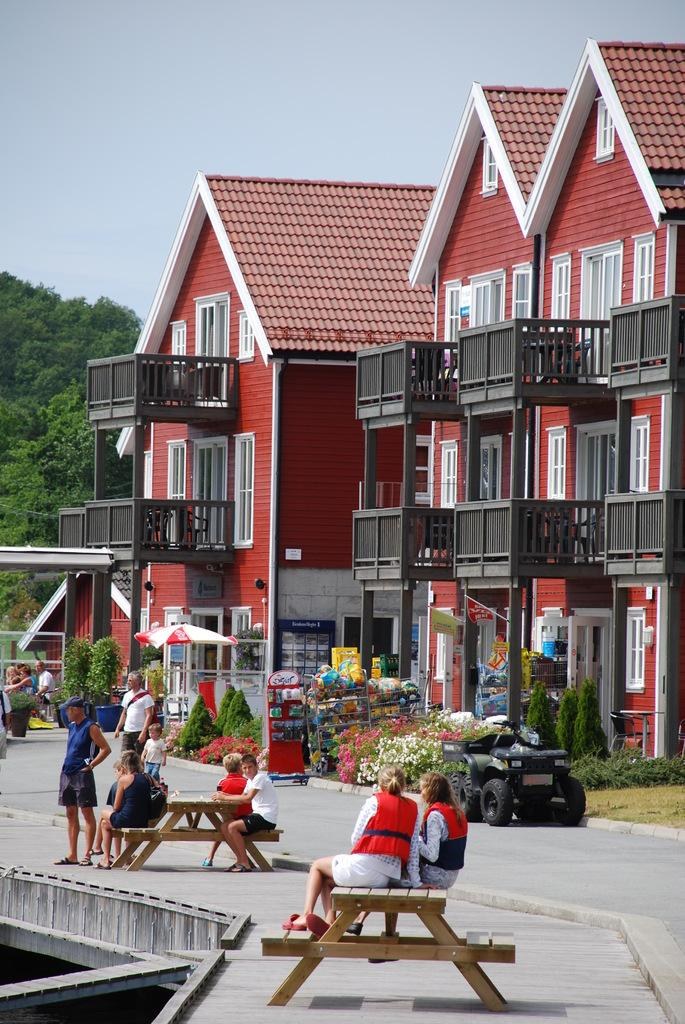How many people are in the image? The number of people in the image is not specified, but there are people present. What is the primary setting or location in the image? The people are in front of a building. What type of expert advice is being given in the image? There is no indication in the image that any expert advice is being given. What type of voyage are the people embarking on in the image? There is no indication in the image that the people are embarking on any voyage. 